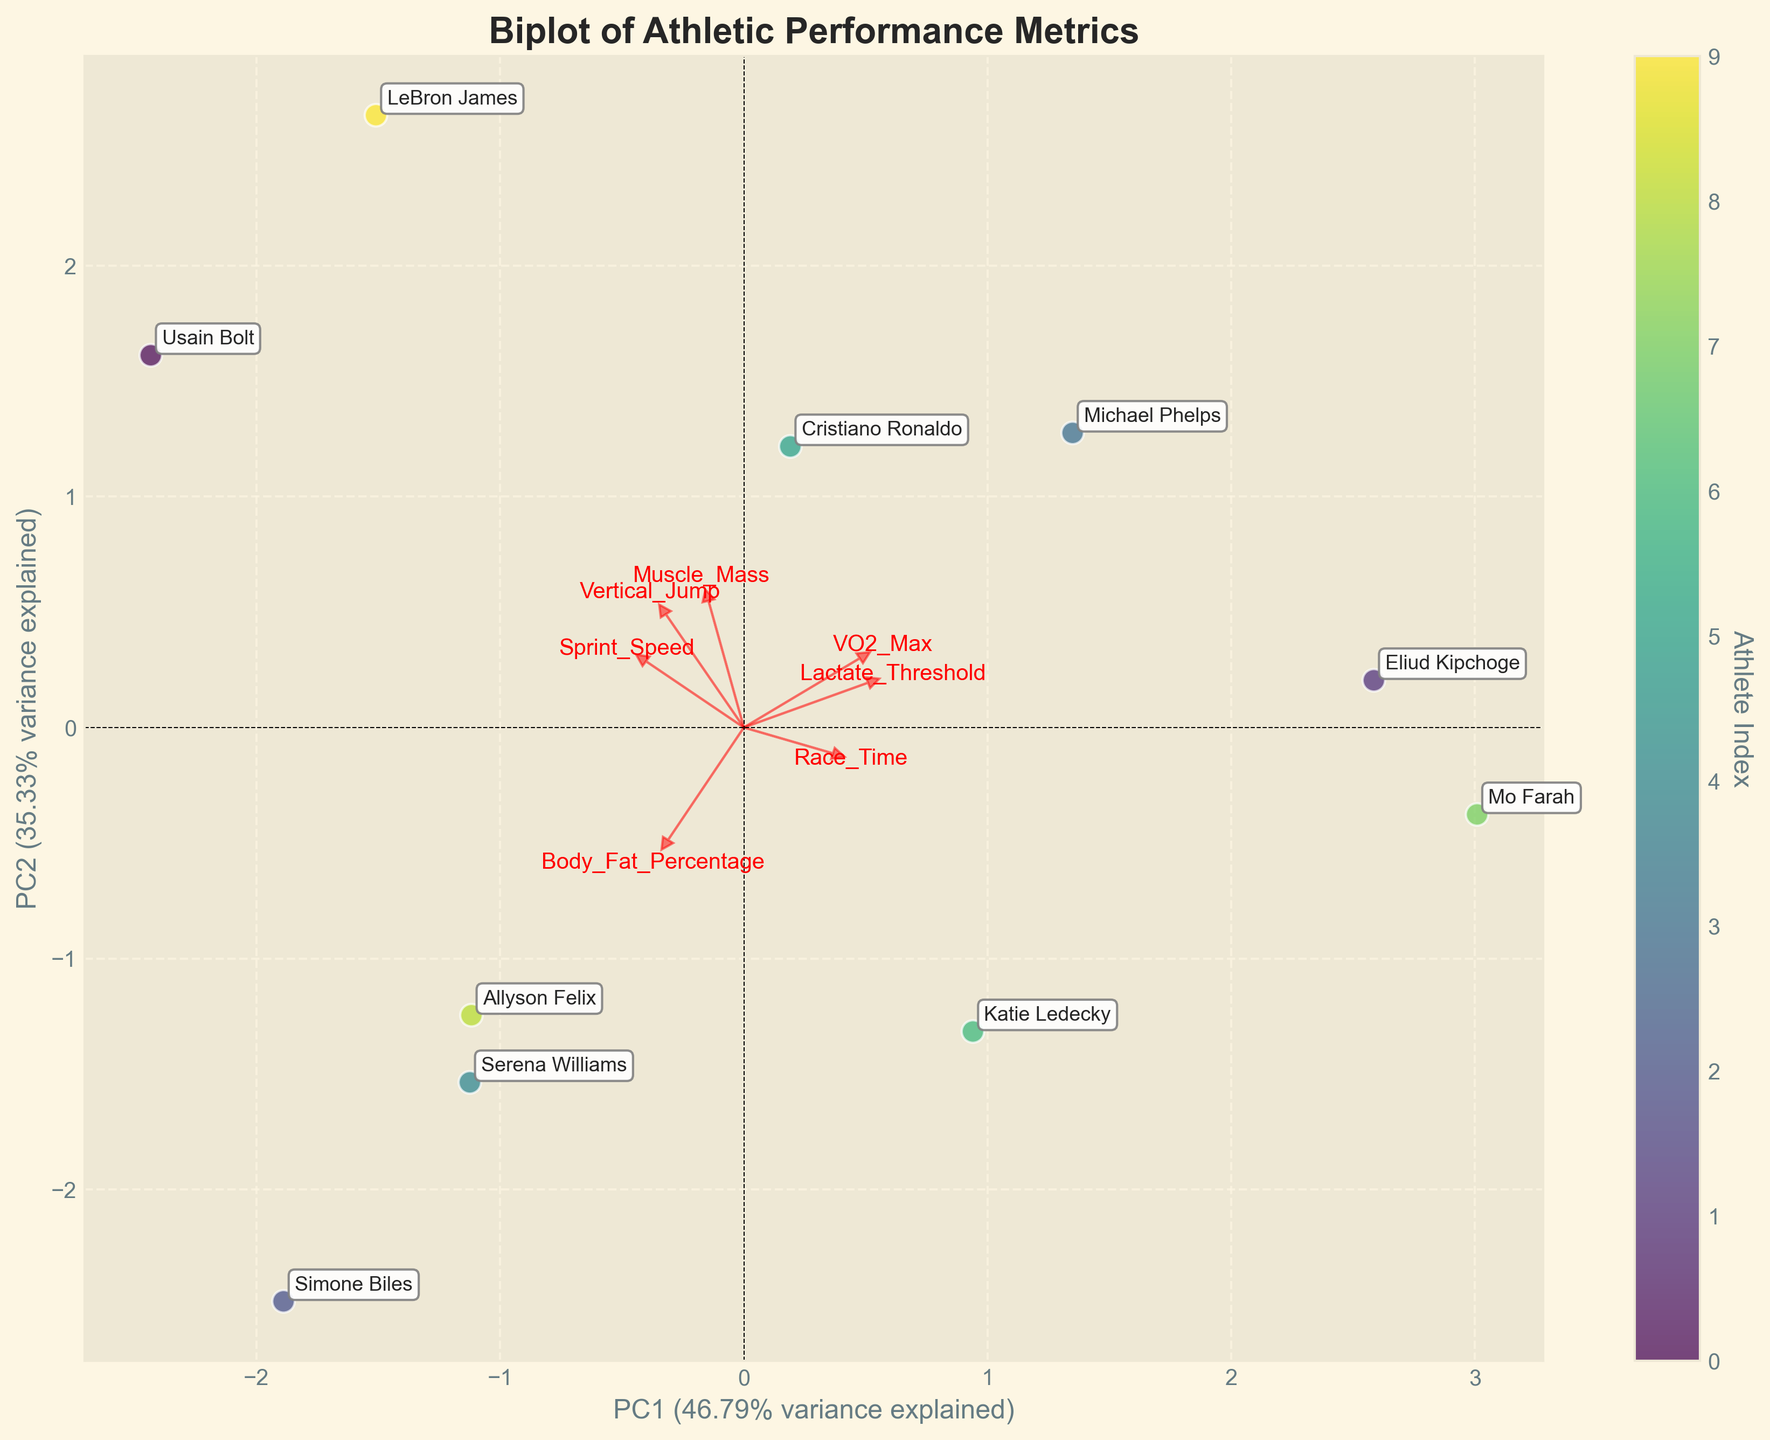what is the title of the biplot? The title is typically at the top of the figure and describes what the plot is about. Observing the figure, the title can be seen clearly.
Answer: Biplot of Athletic Performance Metrics How many athletes are represented in the biplot? Each athlete is represented by a point in the biplot. By counting the distinct points, we can determine the number of athletes.
Answer: 10 Which two variables are plotted as the primary components in the biplot? The axes' labels indicate which principal components are displayed. By looking at the axes, we can assess which components are shown.
Answer: PC1 and PC2 Which athlete is closest to the origin of the biplot? The origin is the point (0,0) on the biplot. The athlete whose point is nearest to this intersection is the closest to the origin.
Answer: Allyson Felix Which athlete is represented by the point with the lowest value on the PC1 axis? The PC1 axis is the x-axis. To find the athlete with the lowest value, we locate the point furthest to the left.
Answer: Simone Biles How is the feature 'Vertical_Jump' oriented relative to 'Sprint_Speed' in the biplot? The orientation of the arrows representing 'Vertical_Jump' and 'Sprint_Speed' shows how these features are correlated. Observing the arrows' directions relative to each other will determine their orientation.
Answer: Similar direction Which athlete clusters closest to 'Muscle_Mass'? The feature vectors (arrows) indicate the direction of each variable. The athlete's point closest to the 'Muscle_Mass' arrow suggests they score high on this metric.
Answer: LeBron James Which feature has the most significant positive loading on PC1? The length of the arrows indicates the loading of each feature on the principal components. The longest arrow along the PC1 axis identifies the largest positive loading.
Answer: VO2_Max Which variable shows a negative correlation with PC1? Variables with arrows pointing in the opposite direction of the PC1 axis are negatively correlated. Observing these directions reveals the negatively correlated variable.
Answer: Body_Fat_Percentage Which athlete has the point furthest to the right on the PC1 axis? To determine this, we observe the athlete's point located furthest to the right of the PC1 axis, indicating the highest value on this axis.
Answer: Eliud Kipchoge 